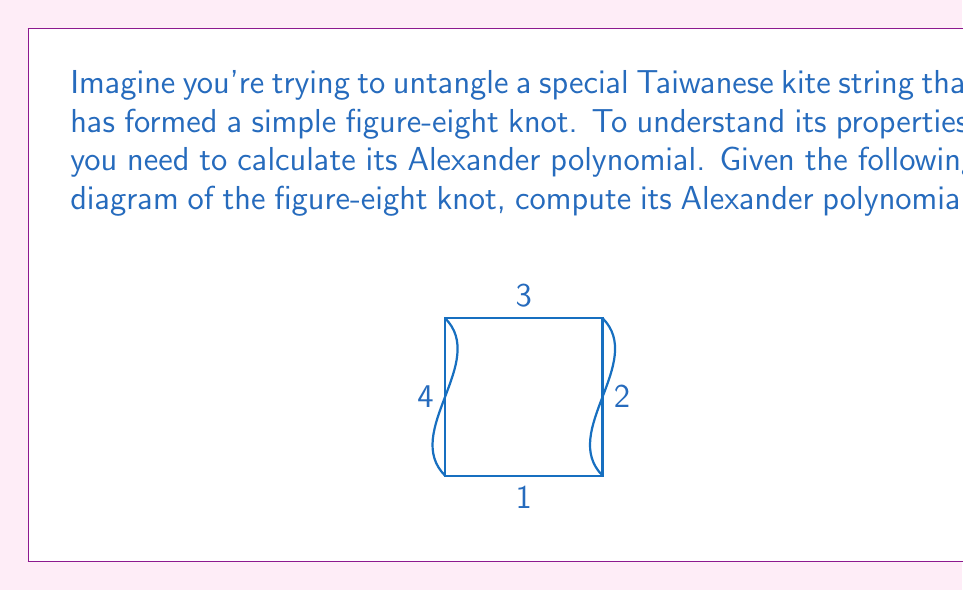Give your solution to this math problem. Let's compute the Alexander polynomial step by step:

1) First, we need to label the arcs and crossings. We've already labeled the arcs 1, 2, 3, and 4.

2) Now, we create a matrix based on the crossings. For each crossing, we write an equation:
   - For an overcrossing: $t \cdot \text{(incoming arc)} - t \cdot \text{(outgoing arc)} + \text{(understrand)}$
   - For an undercrossing: $\text{(incoming arc)} - \text{(outgoing arc)} + (1-t) \cdot \text{(overstrand)}$

3) Our matrix will be:

   $$\begin{pmatrix}
   1-t & t & 0 & -1 \\
   -1 & 1-t & t & 0 \\
   t & 0 & -1 & 1-t \\
   0 & -1 & 1-t & t
   \end{pmatrix}$$

4) To find the Alexander polynomial, we need to calculate the determinant of any 3x3 minor of this matrix and divide by $(t-1)$.

5) Let's choose the minor by removing the last row and column:

   $$\begin{vmatrix}
   1-t & t & 0 \\
   -1 & 1-t & t \\
   t & 0 & -1
   \end{vmatrix}$$

6) Calculating this determinant:
   $$(1-t)((1-t)(-1) - t(0)) - t((-1)(-1) - t(0)) + 0$$
   $$= (1-t)(-(1-t)) - t$$
   $$= -(1-t)^2 - t$$
   $$= -1 + 2t - t^2 - t$$
   $$= -1 + t - t^2$$

7) Dividing by $(t-1)$:
   $$\frac{-1 + t - t^2}{t-1} = -1 - t$$

Therefore, the Alexander polynomial of the figure-eight knot is $-1 - t$.
Answer: $-1 - t$ 